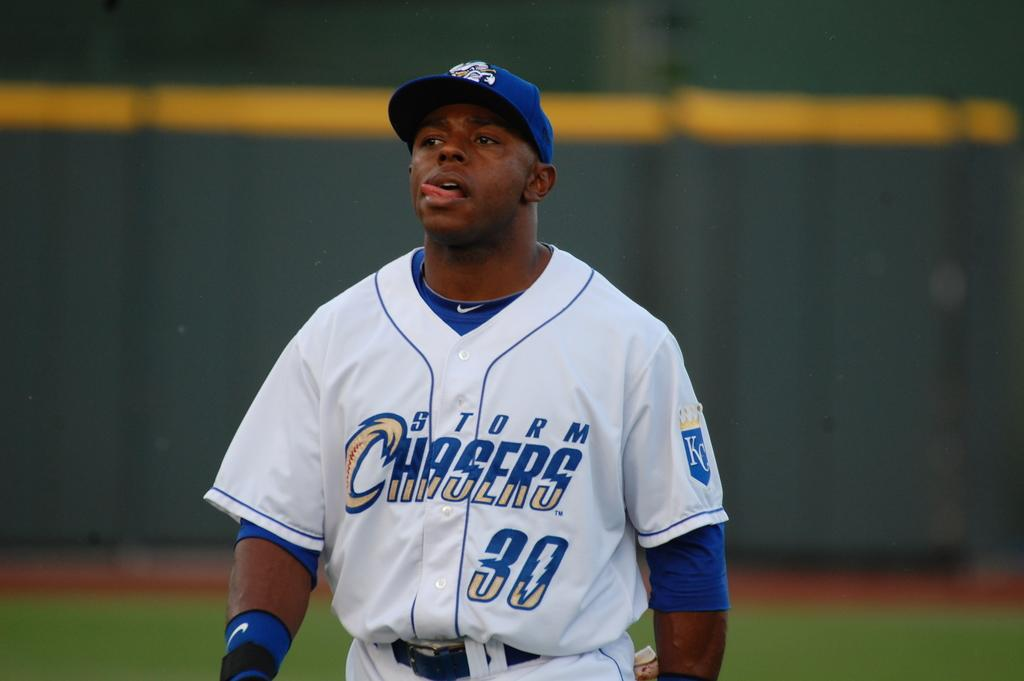Provide a one-sentence caption for the provided image. A player is wearing a Storm Chasers jersey with the number 30 on it. 